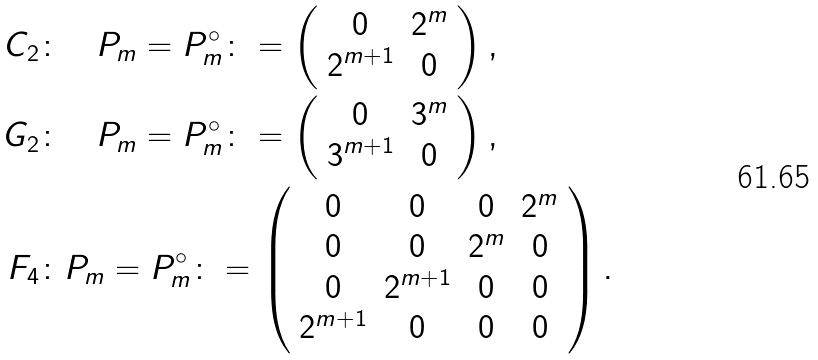Convert formula to latex. <formula><loc_0><loc_0><loc_500><loc_500>C _ { 2 } & \colon \quad P _ { m } = P _ { m } ^ { \circ } \colon = \left ( \begin{array} { c c } 0 & 2 ^ { m } \\ 2 ^ { m + 1 } & 0 \end{array} \right ) , \\ G _ { 2 } & \colon \quad P _ { m } = P _ { m } ^ { \circ } \colon = \left ( \begin{array} { c c } 0 & 3 ^ { m } \\ 3 ^ { m + 1 } & 0 \end{array} \right ) , \\ F _ { 4 } & \colon P _ { m } = P _ { m } ^ { \circ } \colon = \left ( \begin{array} { c c c c } 0 & 0 & 0 & 2 ^ { m } \\ 0 & 0 & 2 ^ { m } & 0 \\ 0 & 2 ^ { m + 1 } & 0 & 0 \\ 2 ^ { m + 1 } & 0 & 0 & 0 \end{array} \right ) .</formula> 